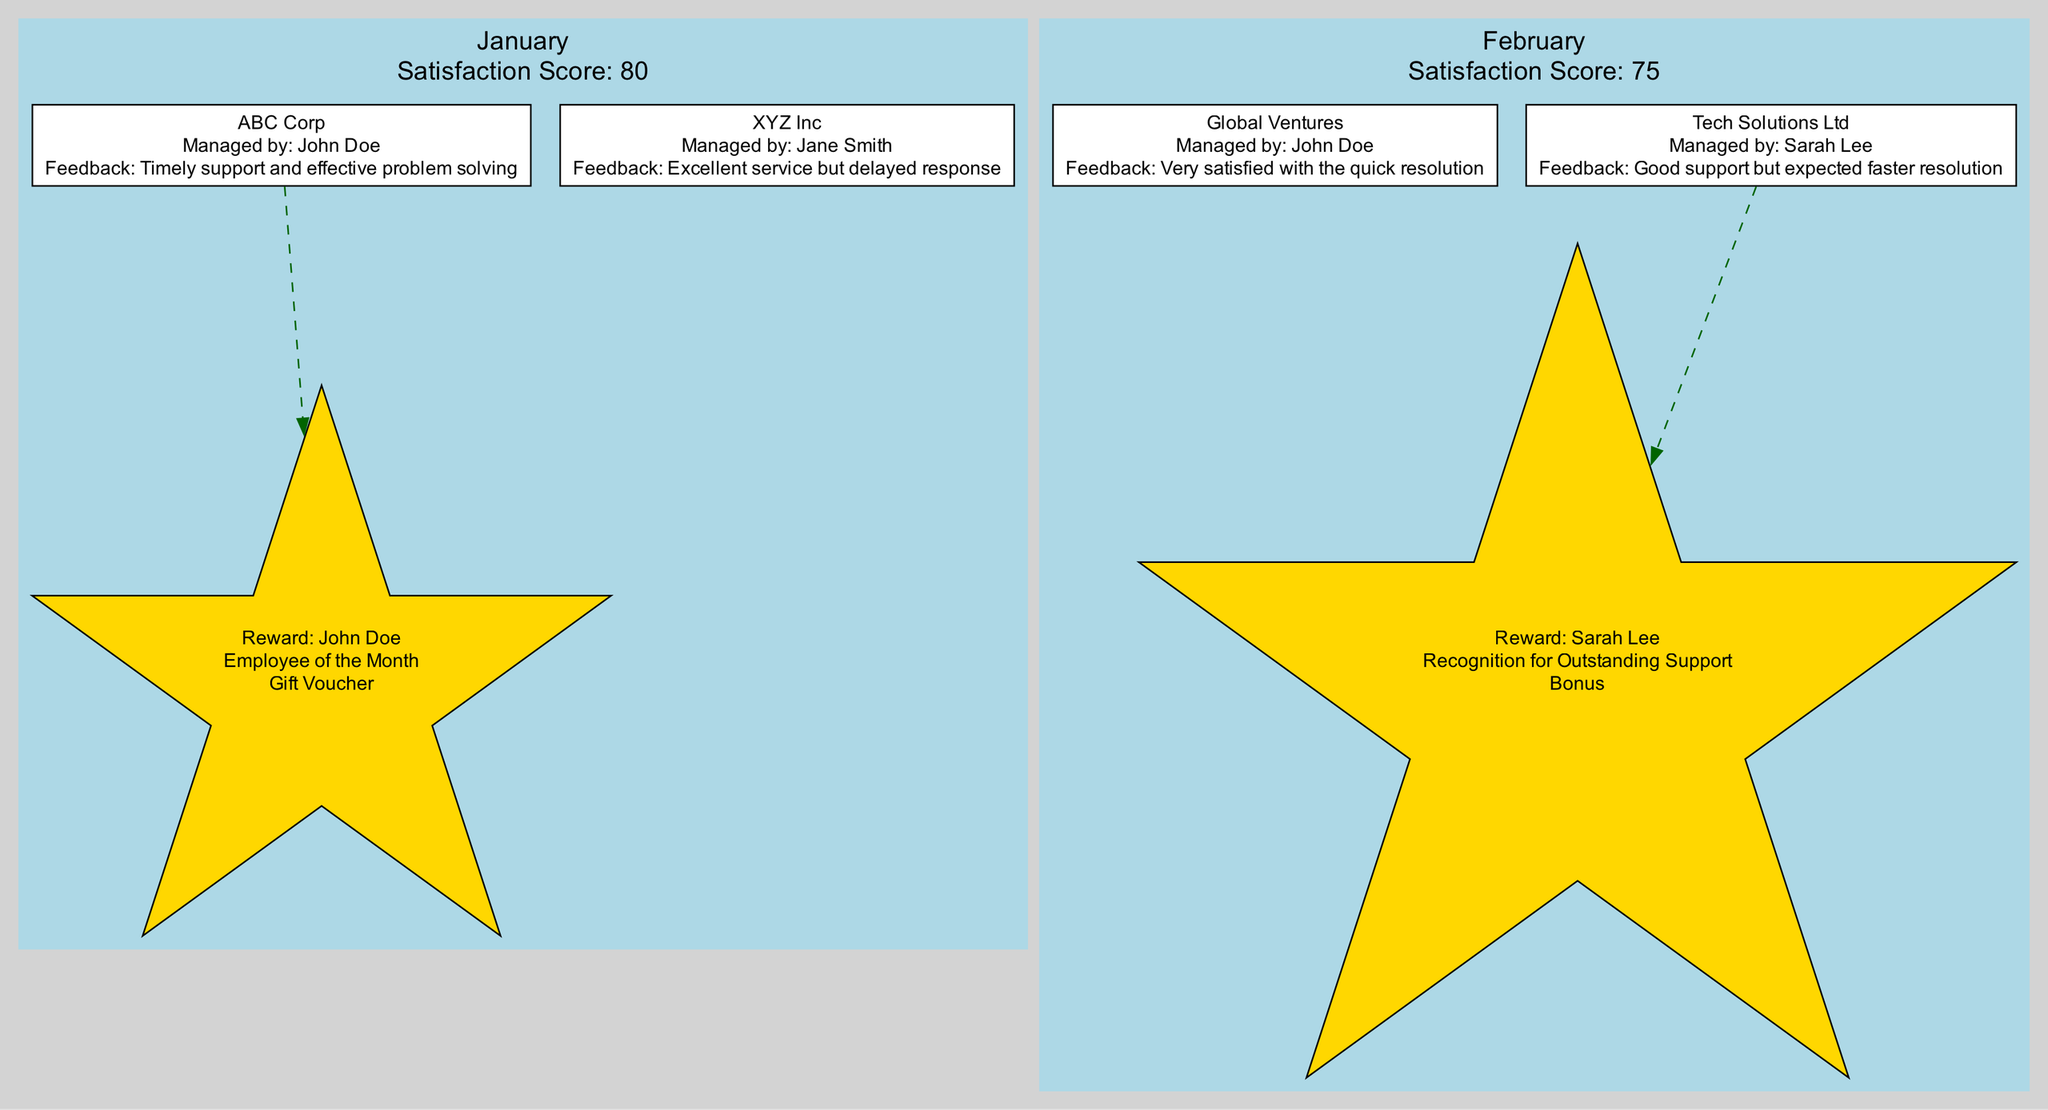What is the satisfaction score for February? The diagram provides the satisfaction score for each month. In the section for February, it clearly lists the score as 75.
Answer: 75 Who managed the client Global Ventures? By examining the key interactions in the February section of the diagram, we see that Global Ventures was managed by John Doe.
Answer: John Doe What recognition did Sarah Lee receive in February? In the February section, there's a rewards node that states Sarah Lee received "Recognition for Outstanding Support."
Answer: Recognition for Outstanding Support How many clients provided feedback in January? In the January section, there are two key interactions listed. Counting these interactions gives the total number of clients providing feedback.
Answer: 2 Which employee received a reward in January? Looking at the rewards section of January, we find that the reward node mentions John Doe received the "Employee of the Month."
Answer: John Doe What feedback did XYZ Inc provide? The diagram shows a key interaction for XYZ Inc in January, where the feedback is listed as "Excellent service but delayed response."
Answer: Excellent service but delayed response Which client was managed by Sarah Lee? The February section lists key interactions, and only one client, Tech Solutions Ltd, was managed by Sarah Lee.
Answer: Tech Solutions Ltd What type of connection exists between John Doe and his reward in January? The diagram uses a dashed edge to connect John Doe to his recognition reward, indicating a positive relationship between his performance and the reward.
Answer: Dashed How many total key interactions are there in the diagram across both months? There are two key interactions listed for January and two for February. Adding these gives the total number of interactions: 2 + 2 = 4.
Answer: 4 